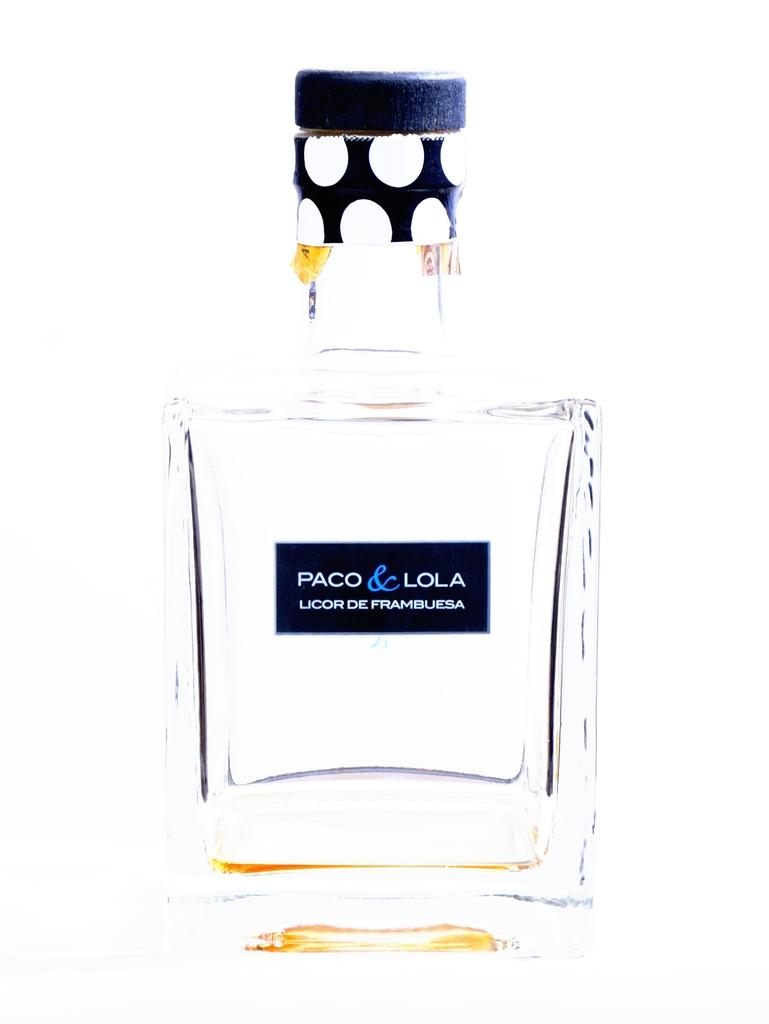<image>
Share a concise interpretation of the image provided. A translucent bottle of Paco & Lola liquor. 